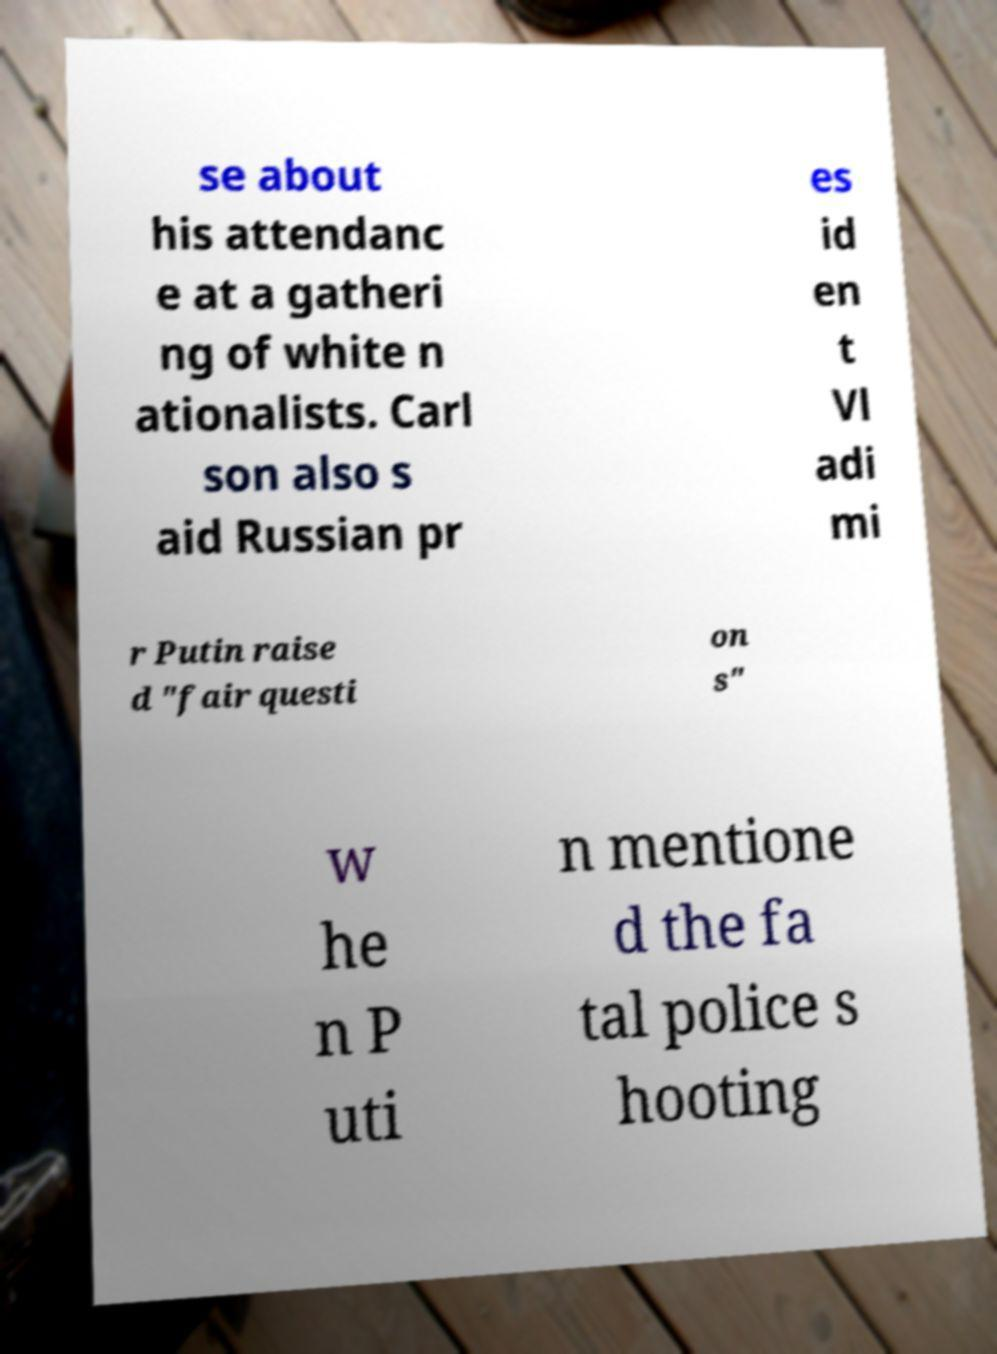Could you assist in decoding the text presented in this image and type it out clearly? se about his attendanc e at a gatheri ng of white n ationalists. Carl son also s aid Russian pr es id en t Vl adi mi r Putin raise d "fair questi on s" w he n P uti n mentione d the fa tal police s hooting 